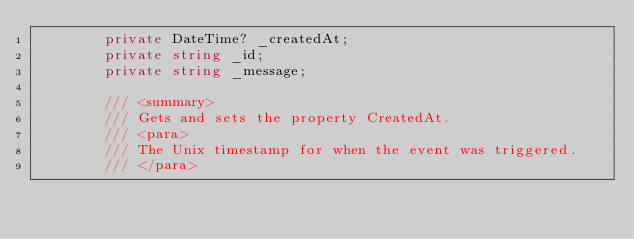Convert code to text. <code><loc_0><loc_0><loc_500><loc_500><_C#_>        private DateTime? _createdAt;
        private string _id;
        private string _message;

        /// <summary>
        /// Gets and sets the property CreatedAt. 
        /// <para>
        /// The Unix timestamp for when the event was triggered.
        /// </para></code> 